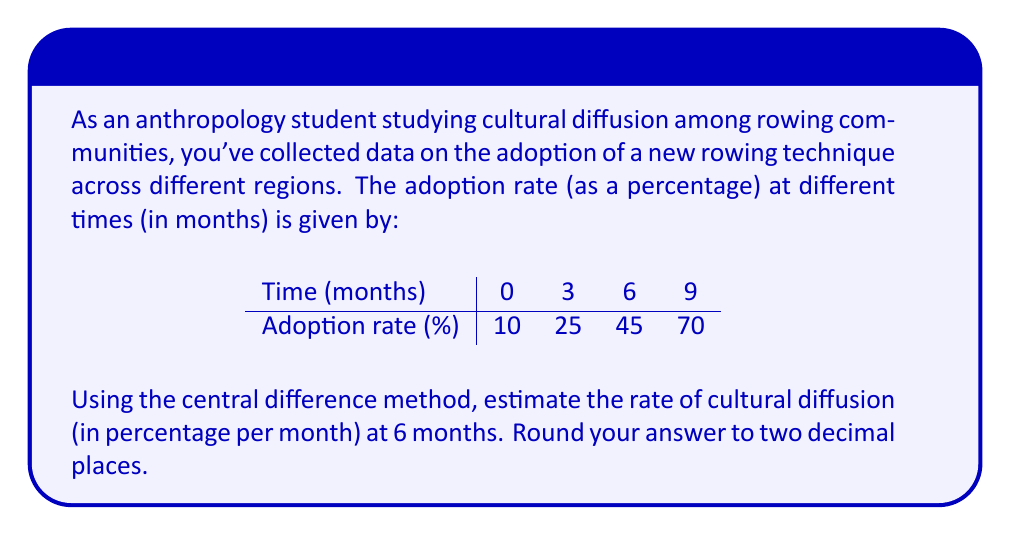Could you help me with this problem? To solve this problem, we'll use the central difference method to approximate the rate of cultural diffusion at 6 months. The central difference formula is:

$$ f'(x) \approx \frac{f(x+h) - f(x-h)}{2h} $$

Where:
- $f'(x)$ is the rate of change (diffusion rate) at time $x$
- $f(x+h)$ is the function value at the next time step
- $f(x-h)$ is the function value at the previous time step
- $h$ is the step size between time points

Steps:
1. Identify the relevant data points:
   At 3 months (x-h): 25%
   At 6 months (x): 45%
   At 9 months (x+h): 70%

2. Determine the step size $h$:
   $h = 9 - 6 = 6 - 3 = 3$ months

3. Apply the central difference formula:
   $$ f'(6) \approx \frac{f(6+3) - f(6-3)}{2(3)} $$
   $$ f'(6) \approx \frac{70 - 25}{2(3)} $$

4. Calculate the result:
   $$ f'(6) \approx \frac{45}{6} = 7.5 $$

5. Round to two decimal places: 7.50

The rate of cultural diffusion at 6 months is approximately 7.50% per month.
Answer: 7.50% per month 